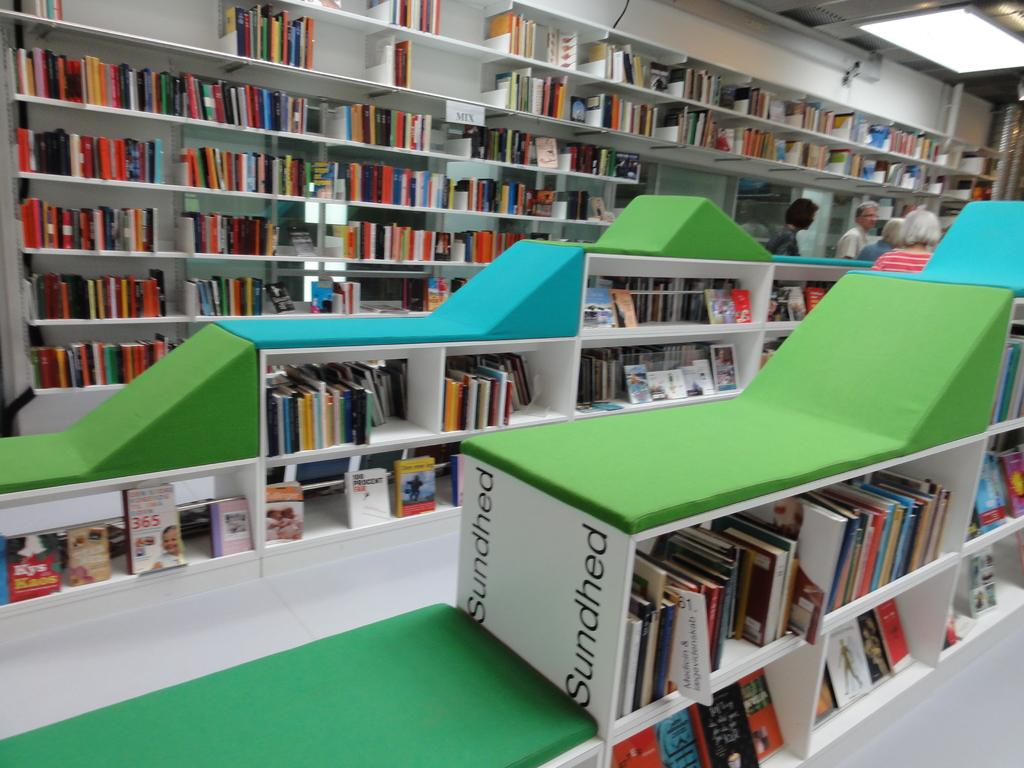<image>
Present a compact description of the photo's key features. shelves containing lots of different books and one unit called sundhed 